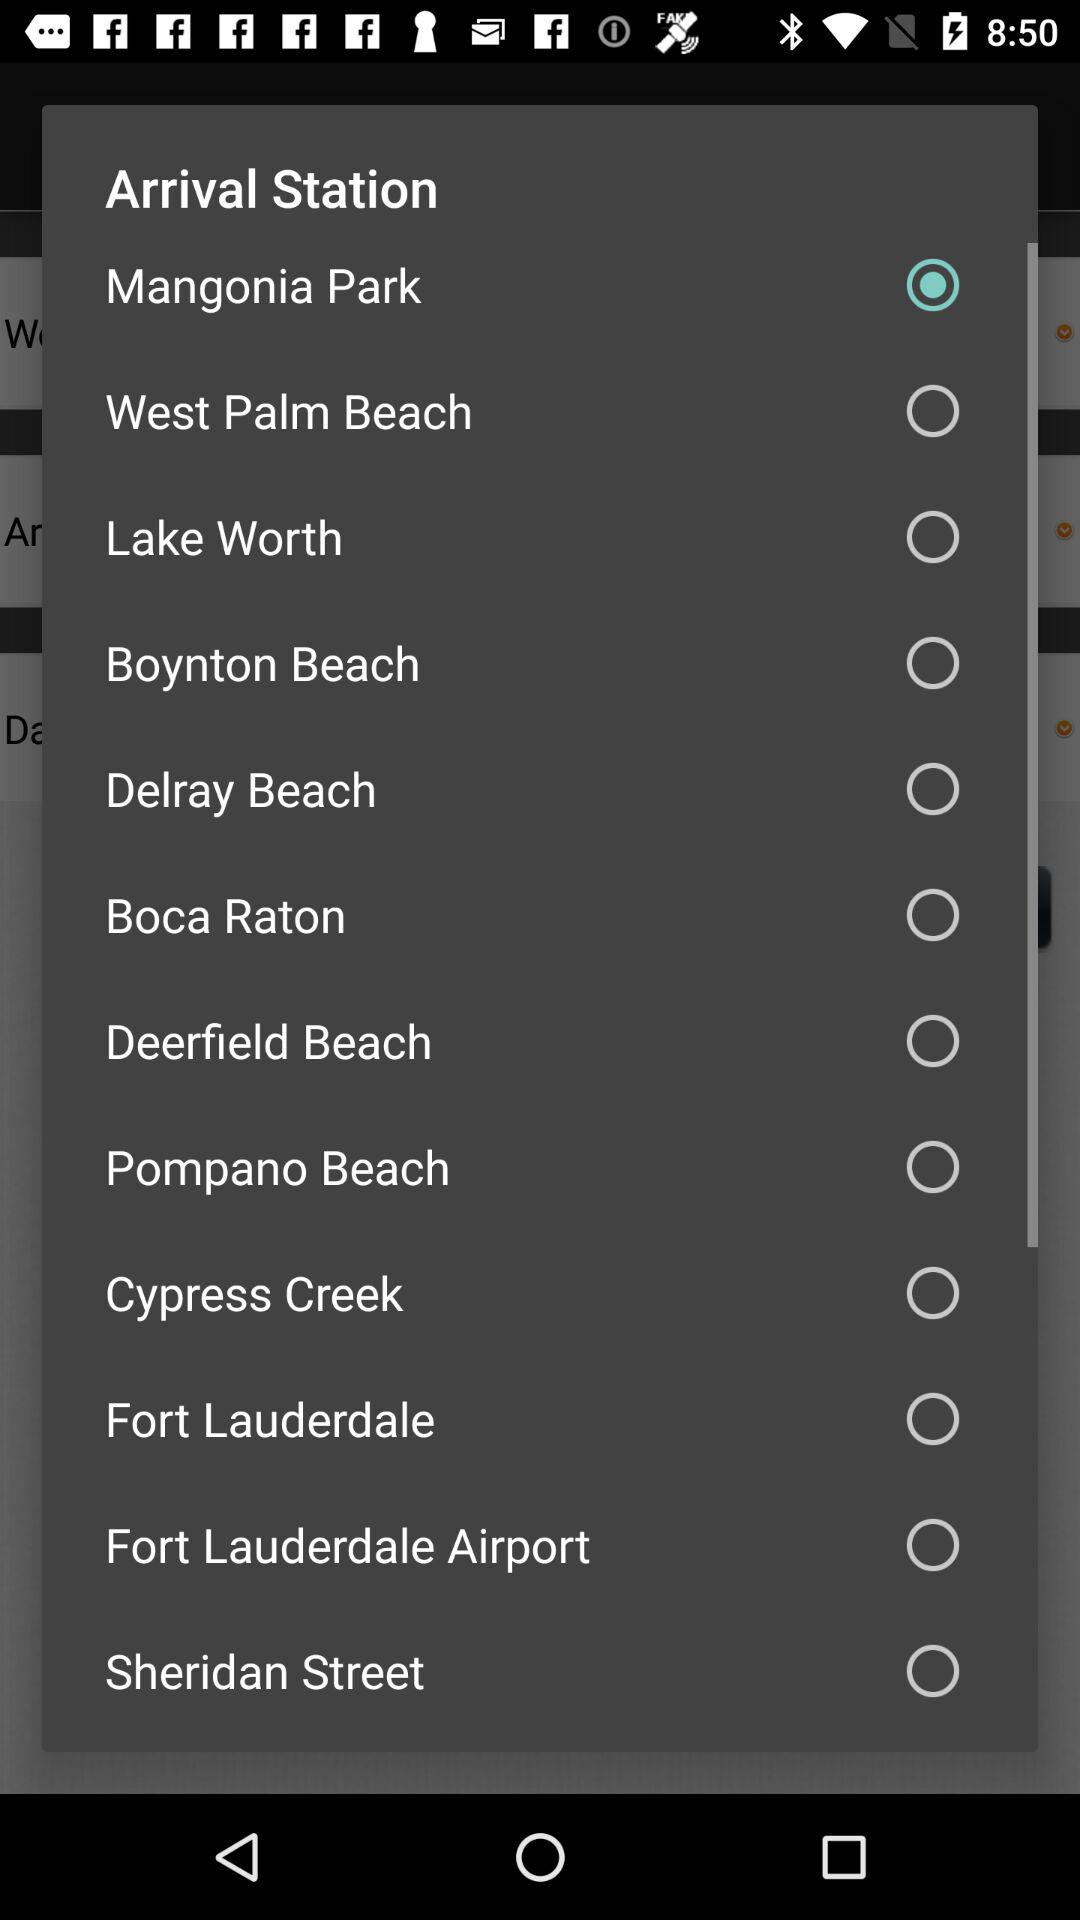What is the selected arrival station? The selected arrival station is "Mangonia Park". 